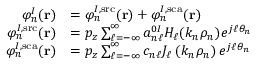Convert formula to latex. <formula><loc_0><loc_0><loc_500><loc_500>\begin{array} { r l } { \varphi _ { n } ^ { I } ( r ) } & { = \varphi _ { n } ^ { I , s r c } ( r ) + \varphi _ { n } ^ { I , s c a } ( r ) } \\ { \varphi _ { n } ^ { I , s r c } ( r ) } & { = p _ { z } \sum _ { \ell = - \infty } ^ { \infty } a _ { n \ell } ^ { 0 I } H _ { \ell } ( k _ { n } \rho _ { n } ) e ^ { j \ell \theta _ { n } } } \\ { \varphi _ { n } ^ { I , s c a } ( r ) } & { = p _ { z } \sum _ { \ell = - \infty } ^ { \infty } c _ { n \ell } J _ { \ell } \left ( k _ { n } \rho _ { n } \right ) e ^ { j \ell \theta _ { n } } } \end{array}</formula> 